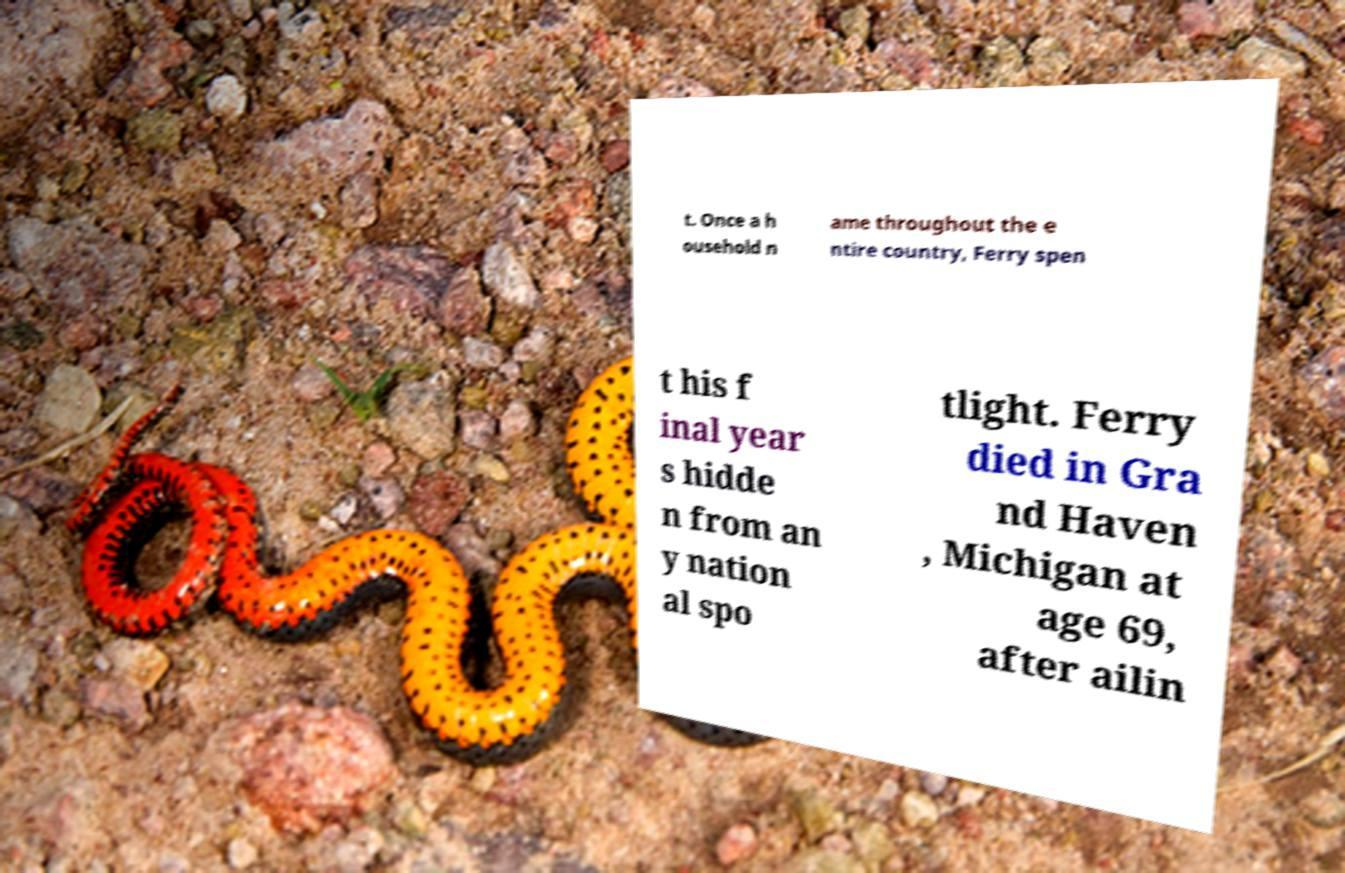Can you read and provide the text displayed in the image?This photo seems to have some interesting text. Can you extract and type it out for me? t. Once a h ousehold n ame throughout the e ntire country, Ferry spen t his f inal year s hidde n from an y nation al spo tlight. Ferry died in Gra nd Haven , Michigan at age 69, after ailin 